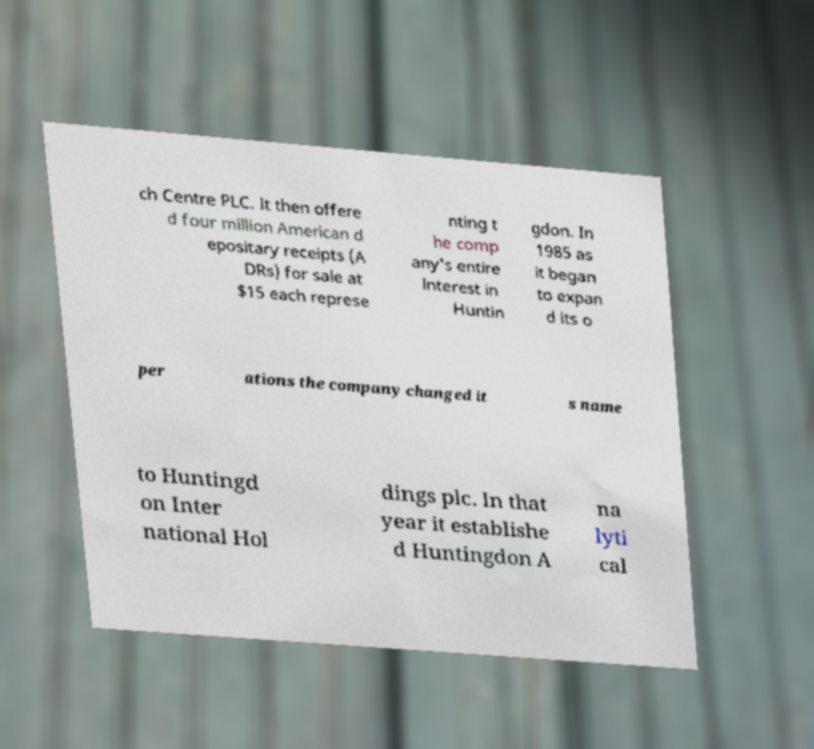Could you assist in decoding the text presented in this image and type it out clearly? ch Centre PLC. It then offere d four million American d epositary receipts (A DRs) for sale at $15 each represe nting t he comp any's entire interest in Huntin gdon. In 1985 as it began to expan d its o per ations the company changed it s name to Huntingd on Inter national Hol dings plc. In that year it establishe d Huntingdon A na lyti cal 